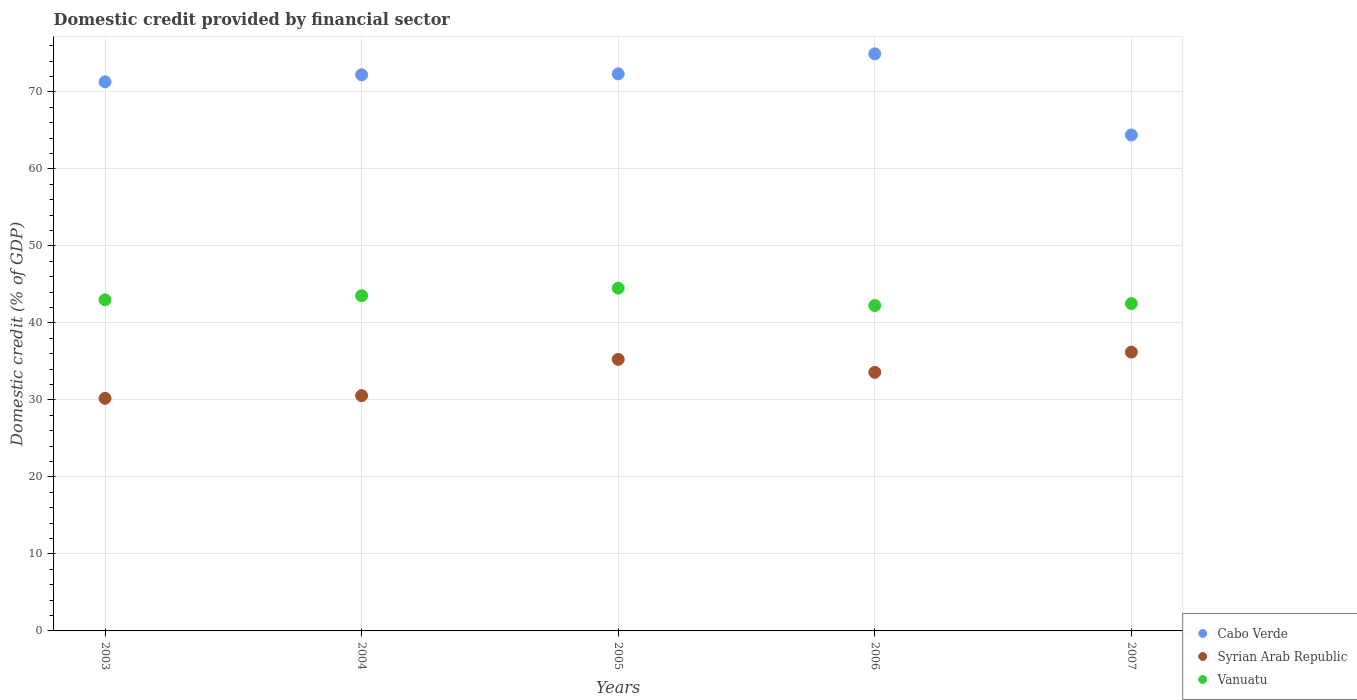What is the domestic credit in Cabo Verde in 2006?
Ensure brevity in your answer.  74.94. Across all years, what is the maximum domestic credit in Syrian Arab Republic?
Provide a succinct answer. 36.2. Across all years, what is the minimum domestic credit in Cabo Verde?
Keep it short and to the point. 64.4. In which year was the domestic credit in Vanuatu minimum?
Offer a terse response. 2006. What is the total domestic credit in Vanuatu in the graph?
Your response must be concise. 215.8. What is the difference between the domestic credit in Cabo Verde in 2005 and that in 2006?
Your response must be concise. -2.61. What is the difference between the domestic credit in Vanuatu in 2006 and the domestic credit in Syrian Arab Republic in 2003?
Your answer should be compact. 12.05. What is the average domestic credit in Vanuatu per year?
Your response must be concise. 43.16. In the year 2004, what is the difference between the domestic credit in Cabo Verde and domestic credit in Vanuatu?
Provide a short and direct response. 28.69. In how many years, is the domestic credit in Vanuatu greater than 50 %?
Make the answer very short. 0. What is the ratio of the domestic credit in Syrian Arab Republic in 2005 to that in 2006?
Make the answer very short. 1.05. Is the domestic credit in Vanuatu in 2003 less than that in 2004?
Keep it short and to the point. Yes. Is the difference between the domestic credit in Cabo Verde in 2005 and 2006 greater than the difference between the domestic credit in Vanuatu in 2005 and 2006?
Your answer should be very brief. No. What is the difference between the highest and the second highest domestic credit in Syrian Arab Republic?
Offer a very short reply. 0.94. What is the difference between the highest and the lowest domestic credit in Syrian Arab Republic?
Your response must be concise. 6. In how many years, is the domestic credit in Vanuatu greater than the average domestic credit in Vanuatu taken over all years?
Give a very brief answer. 2. Is it the case that in every year, the sum of the domestic credit in Syrian Arab Republic and domestic credit in Vanuatu  is greater than the domestic credit in Cabo Verde?
Offer a terse response. Yes. Does the domestic credit in Syrian Arab Republic monotonically increase over the years?
Offer a terse response. No. What is the title of the graph?
Keep it short and to the point. Domestic credit provided by financial sector. Does "Georgia" appear as one of the legend labels in the graph?
Your response must be concise. No. What is the label or title of the X-axis?
Offer a terse response. Years. What is the label or title of the Y-axis?
Provide a succinct answer. Domestic credit (% of GDP). What is the Domestic credit (% of GDP) in Cabo Verde in 2003?
Offer a very short reply. 71.31. What is the Domestic credit (% of GDP) in Syrian Arab Republic in 2003?
Make the answer very short. 30.2. What is the Domestic credit (% of GDP) in Vanuatu in 2003?
Give a very brief answer. 43. What is the Domestic credit (% of GDP) in Cabo Verde in 2004?
Your answer should be compact. 72.22. What is the Domestic credit (% of GDP) in Syrian Arab Republic in 2004?
Provide a succinct answer. 30.55. What is the Domestic credit (% of GDP) of Vanuatu in 2004?
Give a very brief answer. 43.53. What is the Domestic credit (% of GDP) in Cabo Verde in 2005?
Your answer should be very brief. 72.34. What is the Domestic credit (% of GDP) in Syrian Arab Republic in 2005?
Your answer should be compact. 35.26. What is the Domestic credit (% of GDP) in Vanuatu in 2005?
Give a very brief answer. 44.52. What is the Domestic credit (% of GDP) of Cabo Verde in 2006?
Ensure brevity in your answer.  74.94. What is the Domestic credit (% of GDP) of Syrian Arab Republic in 2006?
Provide a succinct answer. 33.58. What is the Domestic credit (% of GDP) in Vanuatu in 2006?
Ensure brevity in your answer.  42.26. What is the Domestic credit (% of GDP) of Cabo Verde in 2007?
Ensure brevity in your answer.  64.4. What is the Domestic credit (% of GDP) of Syrian Arab Republic in 2007?
Your answer should be compact. 36.2. What is the Domestic credit (% of GDP) in Vanuatu in 2007?
Your answer should be compact. 42.5. Across all years, what is the maximum Domestic credit (% of GDP) of Cabo Verde?
Provide a short and direct response. 74.94. Across all years, what is the maximum Domestic credit (% of GDP) of Syrian Arab Republic?
Offer a very short reply. 36.2. Across all years, what is the maximum Domestic credit (% of GDP) of Vanuatu?
Your answer should be compact. 44.52. Across all years, what is the minimum Domestic credit (% of GDP) in Cabo Verde?
Give a very brief answer. 64.4. Across all years, what is the minimum Domestic credit (% of GDP) of Syrian Arab Republic?
Ensure brevity in your answer.  30.2. Across all years, what is the minimum Domestic credit (% of GDP) in Vanuatu?
Give a very brief answer. 42.26. What is the total Domestic credit (% of GDP) of Cabo Verde in the graph?
Provide a short and direct response. 355.21. What is the total Domestic credit (% of GDP) of Syrian Arab Republic in the graph?
Provide a short and direct response. 165.81. What is the total Domestic credit (% of GDP) in Vanuatu in the graph?
Your answer should be very brief. 215.8. What is the difference between the Domestic credit (% of GDP) in Cabo Verde in 2003 and that in 2004?
Make the answer very short. -0.91. What is the difference between the Domestic credit (% of GDP) of Syrian Arab Republic in 2003 and that in 2004?
Your answer should be compact. -0.35. What is the difference between the Domestic credit (% of GDP) of Vanuatu in 2003 and that in 2004?
Offer a terse response. -0.53. What is the difference between the Domestic credit (% of GDP) in Cabo Verde in 2003 and that in 2005?
Your answer should be very brief. -1.03. What is the difference between the Domestic credit (% of GDP) in Syrian Arab Republic in 2003 and that in 2005?
Your answer should be compact. -5.06. What is the difference between the Domestic credit (% of GDP) of Vanuatu in 2003 and that in 2005?
Provide a short and direct response. -1.52. What is the difference between the Domestic credit (% of GDP) of Cabo Verde in 2003 and that in 2006?
Provide a succinct answer. -3.64. What is the difference between the Domestic credit (% of GDP) in Syrian Arab Republic in 2003 and that in 2006?
Make the answer very short. -3.38. What is the difference between the Domestic credit (% of GDP) of Vanuatu in 2003 and that in 2006?
Ensure brevity in your answer.  0.74. What is the difference between the Domestic credit (% of GDP) of Cabo Verde in 2003 and that in 2007?
Offer a very short reply. 6.9. What is the difference between the Domestic credit (% of GDP) in Vanuatu in 2003 and that in 2007?
Provide a succinct answer. 0.49. What is the difference between the Domestic credit (% of GDP) in Cabo Verde in 2004 and that in 2005?
Offer a terse response. -0.12. What is the difference between the Domestic credit (% of GDP) of Syrian Arab Republic in 2004 and that in 2005?
Provide a succinct answer. -4.71. What is the difference between the Domestic credit (% of GDP) in Vanuatu in 2004 and that in 2005?
Give a very brief answer. -0.99. What is the difference between the Domestic credit (% of GDP) in Cabo Verde in 2004 and that in 2006?
Make the answer very short. -2.73. What is the difference between the Domestic credit (% of GDP) of Syrian Arab Republic in 2004 and that in 2006?
Provide a short and direct response. -3.03. What is the difference between the Domestic credit (% of GDP) in Vanuatu in 2004 and that in 2006?
Give a very brief answer. 1.27. What is the difference between the Domestic credit (% of GDP) of Cabo Verde in 2004 and that in 2007?
Ensure brevity in your answer.  7.81. What is the difference between the Domestic credit (% of GDP) in Syrian Arab Republic in 2004 and that in 2007?
Your response must be concise. -5.65. What is the difference between the Domestic credit (% of GDP) in Vanuatu in 2004 and that in 2007?
Your response must be concise. 1.02. What is the difference between the Domestic credit (% of GDP) in Cabo Verde in 2005 and that in 2006?
Give a very brief answer. -2.61. What is the difference between the Domestic credit (% of GDP) in Syrian Arab Republic in 2005 and that in 2006?
Make the answer very short. 1.68. What is the difference between the Domestic credit (% of GDP) of Vanuatu in 2005 and that in 2006?
Ensure brevity in your answer.  2.26. What is the difference between the Domestic credit (% of GDP) in Cabo Verde in 2005 and that in 2007?
Offer a very short reply. 7.93. What is the difference between the Domestic credit (% of GDP) in Syrian Arab Republic in 2005 and that in 2007?
Offer a very short reply. -0.94. What is the difference between the Domestic credit (% of GDP) of Vanuatu in 2005 and that in 2007?
Your answer should be very brief. 2.01. What is the difference between the Domestic credit (% of GDP) in Cabo Verde in 2006 and that in 2007?
Offer a very short reply. 10.54. What is the difference between the Domestic credit (% of GDP) of Syrian Arab Republic in 2006 and that in 2007?
Ensure brevity in your answer.  -2.62. What is the difference between the Domestic credit (% of GDP) of Vanuatu in 2006 and that in 2007?
Make the answer very short. -0.25. What is the difference between the Domestic credit (% of GDP) in Cabo Verde in 2003 and the Domestic credit (% of GDP) in Syrian Arab Republic in 2004?
Your response must be concise. 40.75. What is the difference between the Domestic credit (% of GDP) of Cabo Verde in 2003 and the Domestic credit (% of GDP) of Vanuatu in 2004?
Provide a short and direct response. 27.78. What is the difference between the Domestic credit (% of GDP) in Syrian Arab Republic in 2003 and the Domestic credit (% of GDP) in Vanuatu in 2004?
Give a very brief answer. -13.32. What is the difference between the Domestic credit (% of GDP) of Cabo Verde in 2003 and the Domestic credit (% of GDP) of Syrian Arab Republic in 2005?
Keep it short and to the point. 36.05. What is the difference between the Domestic credit (% of GDP) of Cabo Verde in 2003 and the Domestic credit (% of GDP) of Vanuatu in 2005?
Your answer should be compact. 26.79. What is the difference between the Domestic credit (% of GDP) in Syrian Arab Republic in 2003 and the Domestic credit (% of GDP) in Vanuatu in 2005?
Provide a succinct answer. -14.31. What is the difference between the Domestic credit (% of GDP) of Cabo Verde in 2003 and the Domestic credit (% of GDP) of Syrian Arab Republic in 2006?
Offer a terse response. 37.73. What is the difference between the Domestic credit (% of GDP) of Cabo Verde in 2003 and the Domestic credit (% of GDP) of Vanuatu in 2006?
Your answer should be very brief. 29.05. What is the difference between the Domestic credit (% of GDP) in Syrian Arab Republic in 2003 and the Domestic credit (% of GDP) in Vanuatu in 2006?
Provide a succinct answer. -12.05. What is the difference between the Domestic credit (% of GDP) in Cabo Verde in 2003 and the Domestic credit (% of GDP) in Syrian Arab Republic in 2007?
Offer a very short reply. 35.1. What is the difference between the Domestic credit (% of GDP) in Cabo Verde in 2003 and the Domestic credit (% of GDP) in Vanuatu in 2007?
Provide a short and direct response. 28.8. What is the difference between the Domestic credit (% of GDP) of Syrian Arab Republic in 2003 and the Domestic credit (% of GDP) of Vanuatu in 2007?
Ensure brevity in your answer.  -12.3. What is the difference between the Domestic credit (% of GDP) in Cabo Verde in 2004 and the Domestic credit (% of GDP) in Syrian Arab Republic in 2005?
Make the answer very short. 36.95. What is the difference between the Domestic credit (% of GDP) in Cabo Verde in 2004 and the Domestic credit (% of GDP) in Vanuatu in 2005?
Keep it short and to the point. 27.7. What is the difference between the Domestic credit (% of GDP) in Syrian Arab Republic in 2004 and the Domestic credit (% of GDP) in Vanuatu in 2005?
Keep it short and to the point. -13.96. What is the difference between the Domestic credit (% of GDP) of Cabo Verde in 2004 and the Domestic credit (% of GDP) of Syrian Arab Republic in 2006?
Keep it short and to the point. 38.63. What is the difference between the Domestic credit (% of GDP) of Cabo Verde in 2004 and the Domestic credit (% of GDP) of Vanuatu in 2006?
Offer a terse response. 29.96. What is the difference between the Domestic credit (% of GDP) in Syrian Arab Republic in 2004 and the Domestic credit (% of GDP) in Vanuatu in 2006?
Provide a short and direct response. -11.7. What is the difference between the Domestic credit (% of GDP) of Cabo Verde in 2004 and the Domestic credit (% of GDP) of Syrian Arab Republic in 2007?
Ensure brevity in your answer.  36.01. What is the difference between the Domestic credit (% of GDP) of Cabo Verde in 2004 and the Domestic credit (% of GDP) of Vanuatu in 2007?
Offer a terse response. 29.71. What is the difference between the Domestic credit (% of GDP) of Syrian Arab Republic in 2004 and the Domestic credit (% of GDP) of Vanuatu in 2007?
Your answer should be very brief. -11.95. What is the difference between the Domestic credit (% of GDP) in Cabo Verde in 2005 and the Domestic credit (% of GDP) in Syrian Arab Republic in 2006?
Ensure brevity in your answer.  38.76. What is the difference between the Domestic credit (% of GDP) of Cabo Verde in 2005 and the Domestic credit (% of GDP) of Vanuatu in 2006?
Ensure brevity in your answer.  30.08. What is the difference between the Domestic credit (% of GDP) of Syrian Arab Republic in 2005 and the Domestic credit (% of GDP) of Vanuatu in 2006?
Your answer should be very brief. -6.99. What is the difference between the Domestic credit (% of GDP) in Cabo Verde in 2005 and the Domestic credit (% of GDP) in Syrian Arab Republic in 2007?
Offer a terse response. 36.13. What is the difference between the Domestic credit (% of GDP) of Cabo Verde in 2005 and the Domestic credit (% of GDP) of Vanuatu in 2007?
Offer a very short reply. 29.83. What is the difference between the Domestic credit (% of GDP) of Syrian Arab Republic in 2005 and the Domestic credit (% of GDP) of Vanuatu in 2007?
Give a very brief answer. -7.24. What is the difference between the Domestic credit (% of GDP) in Cabo Verde in 2006 and the Domestic credit (% of GDP) in Syrian Arab Republic in 2007?
Offer a terse response. 38.74. What is the difference between the Domestic credit (% of GDP) in Cabo Verde in 2006 and the Domestic credit (% of GDP) in Vanuatu in 2007?
Ensure brevity in your answer.  32.44. What is the difference between the Domestic credit (% of GDP) of Syrian Arab Republic in 2006 and the Domestic credit (% of GDP) of Vanuatu in 2007?
Your response must be concise. -8.92. What is the average Domestic credit (% of GDP) of Cabo Verde per year?
Ensure brevity in your answer.  71.04. What is the average Domestic credit (% of GDP) in Syrian Arab Republic per year?
Your answer should be very brief. 33.16. What is the average Domestic credit (% of GDP) of Vanuatu per year?
Your answer should be very brief. 43.16. In the year 2003, what is the difference between the Domestic credit (% of GDP) of Cabo Verde and Domestic credit (% of GDP) of Syrian Arab Republic?
Ensure brevity in your answer.  41.1. In the year 2003, what is the difference between the Domestic credit (% of GDP) in Cabo Verde and Domestic credit (% of GDP) in Vanuatu?
Your response must be concise. 28.31. In the year 2003, what is the difference between the Domestic credit (% of GDP) in Syrian Arab Republic and Domestic credit (% of GDP) in Vanuatu?
Provide a short and direct response. -12.79. In the year 2004, what is the difference between the Domestic credit (% of GDP) of Cabo Verde and Domestic credit (% of GDP) of Syrian Arab Republic?
Make the answer very short. 41.66. In the year 2004, what is the difference between the Domestic credit (% of GDP) of Cabo Verde and Domestic credit (% of GDP) of Vanuatu?
Offer a terse response. 28.69. In the year 2004, what is the difference between the Domestic credit (% of GDP) of Syrian Arab Republic and Domestic credit (% of GDP) of Vanuatu?
Your answer should be very brief. -12.97. In the year 2005, what is the difference between the Domestic credit (% of GDP) of Cabo Verde and Domestic credit (% of GDP) of Syrian Arab Republic?
Provide a short and direct response. 37.07. In the year 2005, what is the difference between the Domestic credit (% of GDP) in Cabo Verde and Domestic credit (% of GDP) in Vanuatu?
Ensure brevity in your answer.  27.82. In the year 2005, what is the difference between the Domestic credit (% of GDP) in Syrian Arab Republic and Domestic credit (% of GDP) in Vanuatu?
Ensure brevity in your answer.  -9.26. In the year 2006, what is the difference between the Domestic credit (% of GDP) of Cabo Verde and Domestic credit (% of GDP) of Syrian Arab Republic?
Offer a very short reply. 41.36. In the year 2006, what is the difference between the Domestic credit (% of GDP) in Cabo Verde and Domestic credit (% of GDP) in Vanuatu?
Your answer should be very brief. 32.69. In the year 2006, what is the difference between the Domestic credit (% of GDP) of Syrian Arab Republic and Domestic credit (% of GDP) of Vanuatu?
Make the answer very short. -8.67. In the year 2007, what is the difference between the Domestic credit (% of GDP) of Cabo Verde and Domestic credit (% of GDP) of Syrian Arab Republic?
Offer a terse response. 28.2. In the year 2007, what is the difference between the Domestic credit (% of GDP) in Cabo Verde and Domestic credit (% of GDP) in Vanuatu?
Your answer should be compact. 21.9. In the year 2007, what is the difference between the Domestic credit (% of GDP) of Syrian Arab Republic and Domestic credit (% of GDP) of Vanuatu?
Provide a short and direct response. -6.3. What is the ratio of the Domestic credit (% of GDP) in Cabo Verde in 2003 to that in 2004?
Keep it short and to the point. 0.99. What is the ratio of the Domestic credit (% of GDP) in Vanuatu in 2003 to that in 2004?
Your answer should be compact. 0.99. What is the ratio of the Domestic credit (% of GDP) in Cabo Verde in 2003 to that in 2005?
Make the answer very short. 0.99. What is the ratio of the Domestic credit (% of GDP) in Syrian Arab Republic in 2003 to that in 2005?
Provide a succinct answer. 0.86. What is the ratio of the Domestic credit (% of GDP) in Vanuatu in 2003 to that in 2005?
Keep it short and to the point. 0.97. What is the ratio of the Domestic credit (% of GDP) of Cabo Verde in 2003 to that in 2006?
Make the answer very short. 0.95. What is the ratio of the Domestic credit (% of GDP) in Syrian Arab Republic in 2003 to that in 2006?
Give a very brief answer. 0.9. What is the ratio of the Domestic credit (% of GDP) of Vanuatu in 2003 to that in 2006?
Your answer should be compact. 1.02. What is the ratio of the Domestic credit (% of GDP) of Cabo Verde in 2003 to that in 2007?
Provide a succinct answer. 1.11. What is the ratio of the Domestic credit (% of GDP) in Syrian Arab Republic in 2003 to that in 2007?
Your answer should be compact. 0.83. What is the ratio of the Domestic credit (% of GDP) of Vanuatu in 2003 to that in 2007?
Offer a terse response. 1.01. What is the ratio of the Domestic credit (% of GDP) in Cabo Verde in 2004 to that in 2005?
Keep it short and to the point. 1. What is the ratio of the Domestic credit (% of GDP) of Syrian Arab Republic in 2004 to that in 2005?
Make the answer very short. 0.87. What is the ratio of the Domestic credit (% of GDP) in Vanuatu in 2004 to that in 2005?
Give a very brief answer. 0.98. What is the ratio of the Domestic credit (% of GDP) in Cabo Verde in 2004 to that in 2006?
Your answer should be very brief. 0.96. What is the ratio of the Domestic credit (% of GDP) in Syrian Arab Republic in 2004 to that in 2006?
Offer a very short reply. 0.91. What is the ratio of the Domestic credit (% of GDP) in Vanuatu in 2004 to that in 2006?
Your answer should be very brief. 1.03. What is the ratio of the Domestic credit (% of GDP) in Cabo Verde in 2004 to that in 2007?
Your answer should be very brief. 1.12. What is the ratio of the Domestic credit (% of GDP) of Syrian Arab Republic in 2004 to that in 2007?
Offer a very short reply. 0.84. What is the ratio of the Domestic credit (% of GDP) of Vanuatu in 2004 to that in 2007?
Keep it short and to the point. 1.02. What is the ratio of the Domestic credit (% of GDP) in Cabo Verde in 2005 to that in 2006?
Your answer should be very brief. 0.97. What is the ratio of the Domestic credit (% of GDP) of Syrian Arab Republic in 2005 to that in 2006?
Your answer should be compact. 1.05. What is the ratio of the Domestic credit (% of GDP) of Vanuatu in 2005 to that in 2006?
Give a very brief answer. 1.05. What is the ratio of the Domestic credit (% of GDP) in Cabo Verde in 2005 to that in 2007?
Give a very brief answer. 1.12. What is the ratio of the Domestic credit (% of GDP) in Syrian Arab Republic in 2005 to that in 2007?
Offer a terse response. 0.97. What is the ratio of the Domestic credit (% of GDP) in Vanuatu in 2005 to that in 2007?
Provide a short and direct response. 1.05. What is the ratio of the Domestic credit (% of GDP) of Cabo Verde in 2006 to that in 2007?
Your answer should be compact. 1.16. What is the ratio of the Domestic credit (% of GDP) in Syrian Arab Republic in 2006 to that in 2007?
Provide a succinct answer. 0.93. What is the difference between the highest and the second highest Domestic credit (% of GDP) of Cabo Verde?
Provide a succinct answer. 2.61. What is the difference between the highest and the second highest Domestic credit (% of GDP) of Syrian Arab Republic?
Your response must be concise. 0.94. What is the difference between the highest and the second highest Domestic credit (% of GDP) of Vanuatu?
Make the answer very short. 0.99. What is the difference between the highest and the lowest Domestic credit (% of GDP) in Cabo Verde?
Ensure brevity in your answer.  10.54. What is the difference between the highest and the lowest Domestic credit (% of GDP) in Vanuatu?
Offer a terse response. 2.26. 